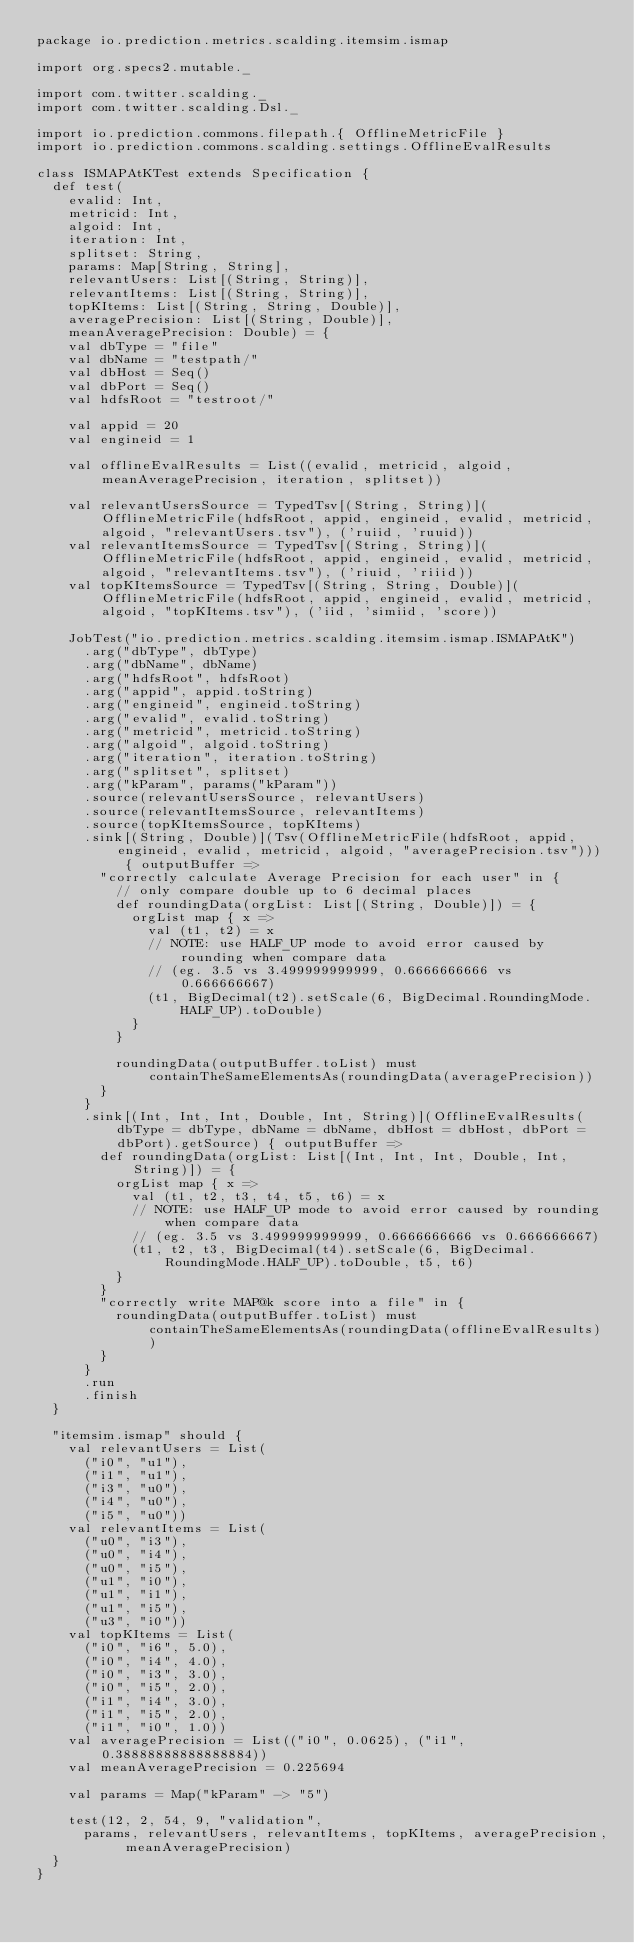Convert code to text. <code><loc_0><loc_0><loc_500><loc_500><_Scala_>package io.prediction.metrics.scalding.itemsim.ismap

import org.specs2.mutable._

import com.twitter.scalding._
import com.twitter.scalding.Dsl._

import io.prediction.commons.filepath.{ OfflineMetricFile }
import io.prediction.commons.scalding.settings.OfflineEvalResults

class ISMAPAtKTest extends Specification {
  def test(
    evalid: Int,
    metricid: Int,
    algoid: Int,
    iteration: Int,
    splitset: String,
    params: Map[String, String],
    relevantUsers: List[(String, String)],
    relevantItems: List[(String, String)],
    topKItems: List[(String, String, Double)],
    averagePrecision: List[(String, Double)],
    meanAveragePrecision: Double) = {
    val dbType = "file"
    val dbName = "testpath/"
    val dbHost = Seq()
    val dbPort = Seq()
    val hdfsRoot = "testroot/"

    val appid = 20
    val engineid = 1

    val offlineEvalResults = List((evalid, metricid, algoid, meanAveragePrecision, iteration, splitset))

    val relevantUsersSource = TypedTsv[(String, String)](OfflineMetricFile(hdfsRoot, appid, engineid, evalid, metricid, algoid, "relevantUsers.tsv"), ('ruiid, 'ruuid))
    val relevantItemsSource = TypedTsv[(String, String)](OfflineMetricFile(hdfsRoot, appid, engineid, evalid, metricid, algoid, "relevantItems.tsv"), ('riuid, 'riiid))
    val topKItemsSource = TypedTsv[(String, String, Double)](OfflineMetricFile(hdfsRoot, appid, engineid, evalid, metricid, algoid, "topKItems.tsv"), ('iid, 'simiid, 'score))

    JobTest("io.prediction.metrics.scalding.itemsim.ismap.ISMAPAtK")
      .arg("dbType", dbType)
      .arg("dbName", dbName)
      .arg("hdfsRoot", hdfsRoot)
      .arg("appid", appid.toString)
      .arg("engineid", engineid.toString)
      .arg("evalid", evalid.toString)
      .arg("metricid", metricid.toString)
      .arg("algoid", algoid.toString)
      .arg("iteration", iteration.toString)
      .arg("splitset", splitset)
      .arg("kParam", params("kParam"))
      .source(relevantUsersSource, relevantUsers)
      .source(relevantItemsSource, relevantItems)
      .source(topKItemsSource, topKItems)
      .sink[(String, Double)](Tsv(OfflineMetricFile(hdfsRoot, appid, engineid, evalid, metricid, algoid, "averagePrecision.tsv"))) { outputBuffer =>
        "correctly calculate Average Precision for each user" in {
          // only compare double up to 6 decimal places
          def roundingData(orgList: List[(String, Double)]) = {
            orgList map { x =>
              val (t1, t2) = x
              // NOTE: use HALF_UP mode to avoid error caused by rounding when compare data
              // (eg. 3.5 vs 3.499999999999, 0.6666666666 vs 0.666666667)
              (t1, BigDecimal(t2).setScale(6, BigDecimal.RoundingMode.HALF_UP).toDouble)
            }
          }

          roundingData(outputBuffer.toList) must containTheSameElementsAs(roundingData(averagePrecision))
        }
      }
      .sink[(Int, Int, Int, Double, Int, String)](OfflineEvalResults(dbType = dbType, dbName = dbName, dbHost = dbHost, dbPort = dbPort).getSource) { outputBuffer =>
        def roundingData(orgList: List[(Int, Int, Int, Double, Int, String)]) = {
          orgList map { x =>
            val (t1, t2, t3, t4, t5, t6) = x
            // NOTE: use HALF_UP mode to avoid error caused by rounding when compare data
            // (eg. 3.5 vs 3.499999999999, 0.6666666666 vs 0.666666667)
            (t1, t2, t3, BigDecimal(t4).setScale(6, BigDecimal.RoundingMode.HALF_UP).toDouble, t5, t6)
          }
        }
        "correctly write MAP@k score into a file" in {
          roundingData(outputBuffer.toList) must containTheSameElementsAs(roundingData(offlineEvalResults))
        }
      }
      .run
      .finish
  }

  "itemsim.ismap" should {
    val relevantUsers = List(
      ("i0", "u1"),
      ("i1", "u1"),
      ("i3", "u0"),
      ("i4", "u0"),
      ("i5", "u0"))
    val relevantItems = List(
      ("u0", "i3"),
      ("u0", "i4"),
      ("u0", "i5"),
      ("u1", "i0"),
      ("u1", "i1"),
      ("u1", "i5"),
      ("u3", "i0"))
    val topKItems = List(
      ("i0", "i6", 5.0),
      ("i0", "i4", 4.0),
      ("i0", "i3", 3.0),
      ("i0", "i5", 2.0),
      ("i1", "i4", 3.0),
      ("i1", "i5", 2.0),
      ("i1", "i0", 1.0))
    val averagePrecision = List(("i0", 0.0625), ("i1", 0.38888888888888884))
    val meanAveragePrecision = 0.225694

    val params = Map("kParam" -> "5")

    test(12, 2, 54, 9, "validation",
      params, relevantUsers, relevantItems, topKItems, averagePrecision, meanAveragePrecision)
  }
}
</code> 